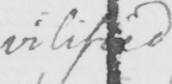What text is written in this handwritten line? vilified 